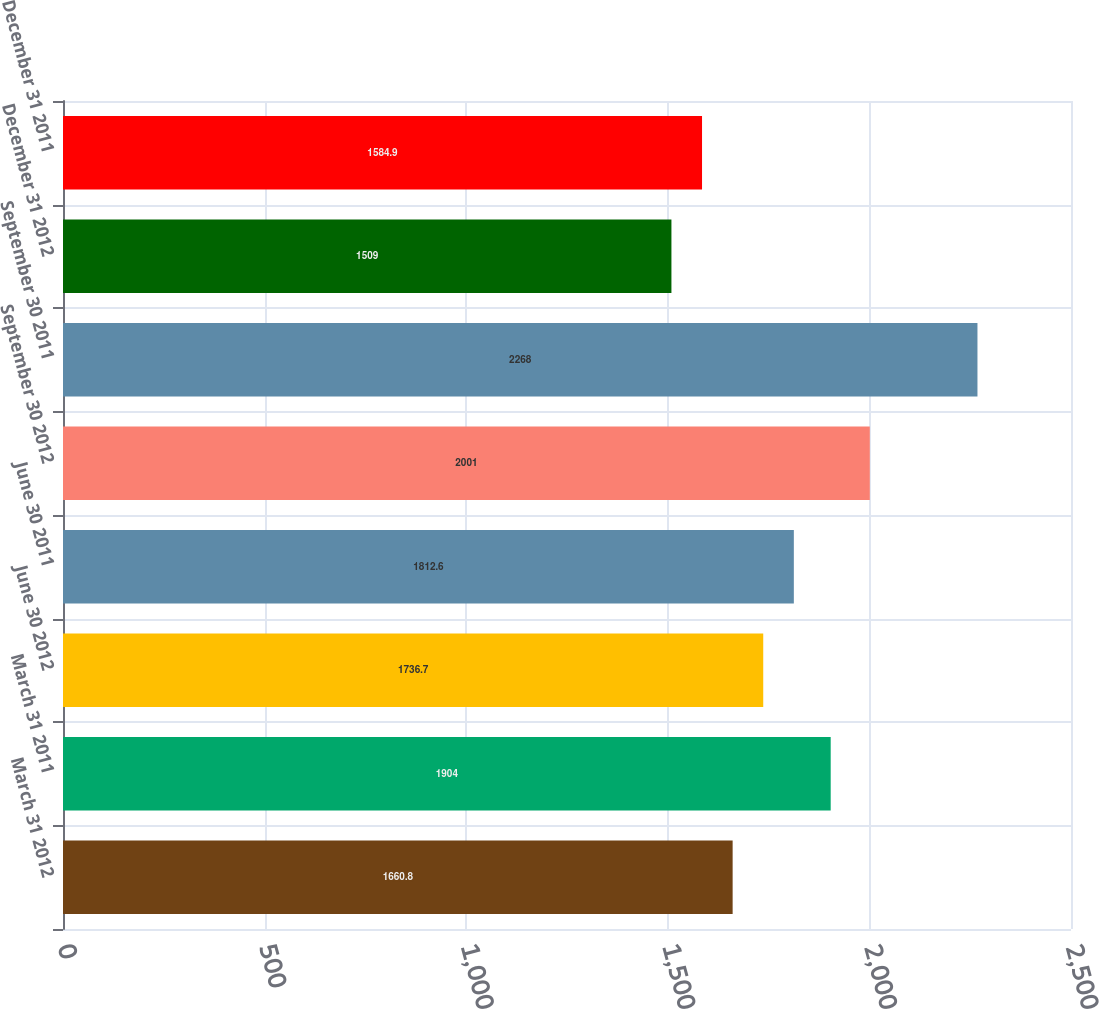<chart> <loc_0><loc_0><loc_500><loc_500><bar_chart><fcel>March 31 2012<fcel>March 31 2011<fcel>June 30 2012<fcel>June 30 2011<fcel>September 30 2012<fcel>September 30 2011<fcel>December 31 2012<fcel>December 31 2011<nl><fcel>1660.8<fcel>1904<fcel>1736.7<fcel>1812.6<fcel>2001<fcel>2268<fcel>1509<fcel>1584.9<nl></chart> 